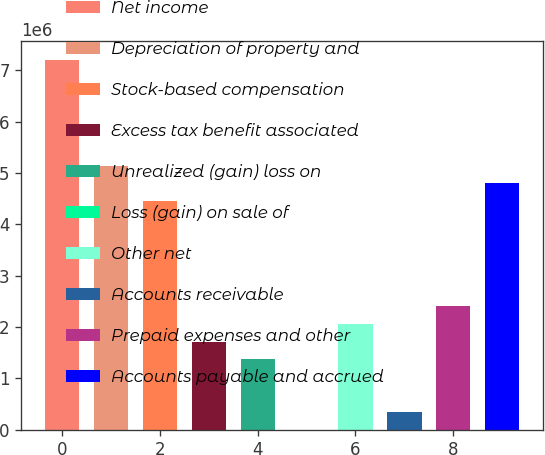Convert chart to OTSL. <chart><loc_0><loc_0><loc_500><loc_500><bar_chart><fcel>Net income<fcel>Depreciation of property and<fcel>Stock-based compensation<fcel>Excess tax benefit associated<fcel>Unrealized (gain) loss on<fcel>Loss (gain) on sale of<fcel>Other net<fcel>Accounts receivable<fcel>Prepaid expenses and other<fcel>Accounts payable and accrued<nl><fcel>7.20018e+06<fcel>5.14299e+06<fcel>4.45726e+06<fcel>1.71433e+06<fcel>1.37147e+06<fcel>5<fcel>2.0572e+06<fcel>342870<fcel>2.40006e+06<fcel>4.80012e+06<nl></chart> 